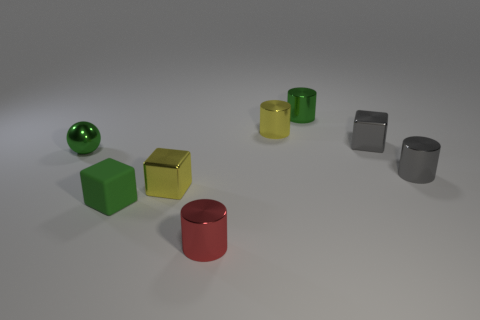Subtract all cyan balls. Subtract all purple cylinders. How many balls are left? 1 Add 1 tiny red shiny things. How many objects exist? 9 Subtract all cubes. How many objects are left? 5 Subtract 0 cyan cylinders. How many objects are left? 8 Subtract all small gray metal objects. Subtract all green cylinders. How many objects are left? 5 Add 3 small shiny cubes. How many small shiny cubes are left? 5 Add 7 small yellow balls. How many small yellow balls exist? 7 